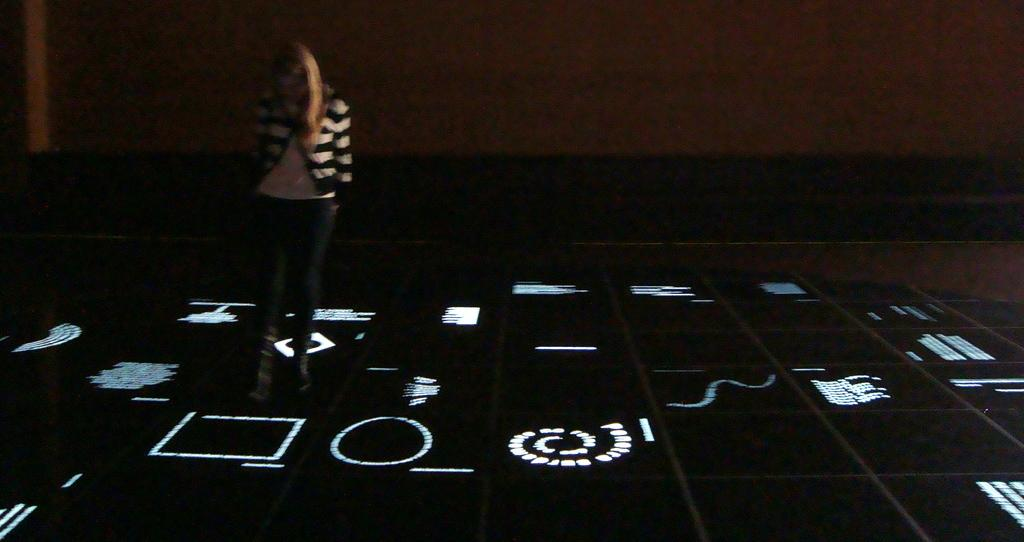Who is the main subject on the left side of the image? There is a lady standing on the left side of the image. What can be seen in the background of the image? There is a wall in the background of the image. What is visible at the bottom of the image? There is a floor visible at the bottom of the image. What type of meat is the lady holding in the image? There is no meat present in the image; the lady is not holding any food item. 